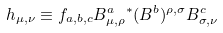<formula> <loc_0><loc_0><loc_500><loc_500>h _ { \mu , \nu } \equiv f _ { a , b , c } B ^ { a } _ { \mu , \rho } { ^ { * } } ( B ^ { b } ) ^ { \rho , \sigma } B ^ { c } _ { \sigma , \nu }</formula> 